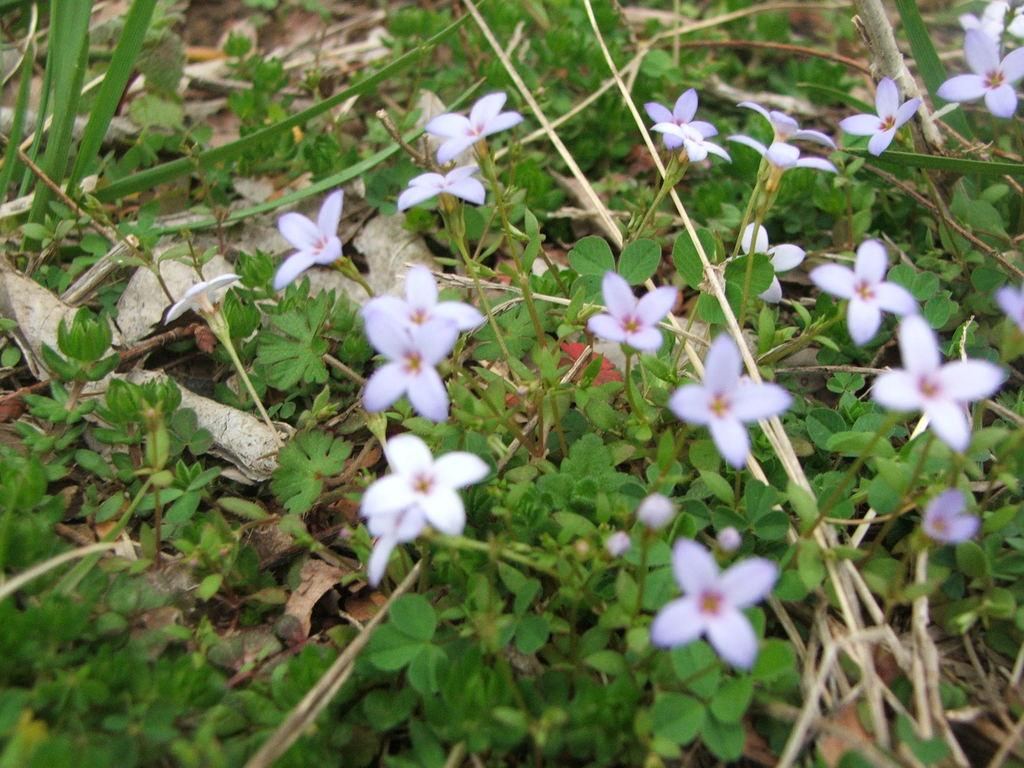What type of vegetation can be seen in the image? There are flowers and green plants in the image. What is the condition of the leaves on the grass in the image? There are dry leaves on the grass in the image. What type of stick can be seen in the image? There is no stick present in the image. How many toes are visible in the image? There are no toes visible in the image. 